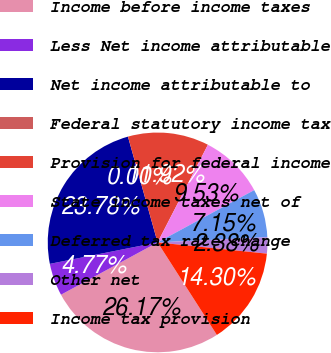Convert chart to OTSL. <chart><loc_0><loc_0><loc_500><loc_500><pie_chart><fcel>Income before income taxes<fcel>Less Net income attributable<fcel>Net income attributable to<fcel>Federal statutory income tax<fcel>Provision for federal income<fcel>State income taxes net of<fcel>Deferred tax rate change<fcel>Other net<fcel>Income tax provision<nl><fcel>26.17%<fcel>4.77%<fcel>23.78%<fcel>0.0%<fcel>11.92%<fcel>9.53%<fcel>7.15%<fcel>2.38%<fcel>14.3%<nl></chart> 